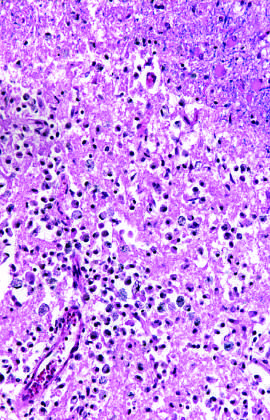does an area of infarction show the presence of macrophages and surrounding reactive gliosis by day 10?
Answer the question using a single word or phrase. Yes 